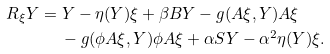<formula> <loc_0><loc_0><loc_500><loc_500>R _ { \xi } Y & = Y - { \eta } ( Y ) \xi + { \beta } B Y - g ( A \xi , Y ) A { \xi } \\ & \quad \ - g ( \phi A \xi , Y ) \phi A \xi + { \alpha } S Y - \alpha ^ { 2 } \eta ( Y ) \xi .</formula> 